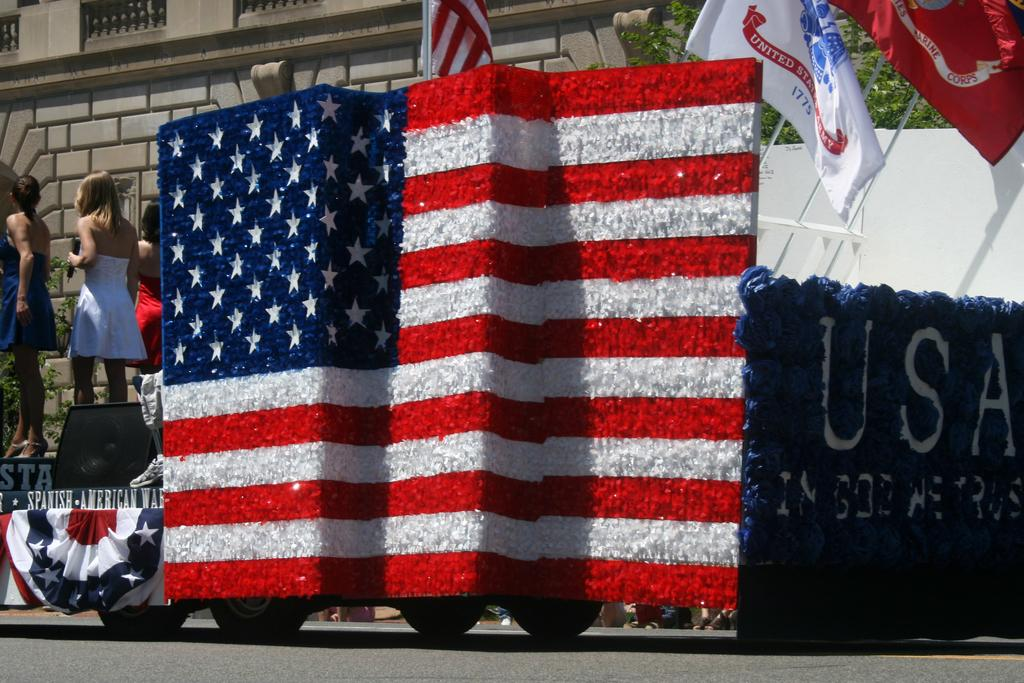<image>
Render a clear and concise summary of the photo. At a parade a us flag themed float has USA written on the back of it. 